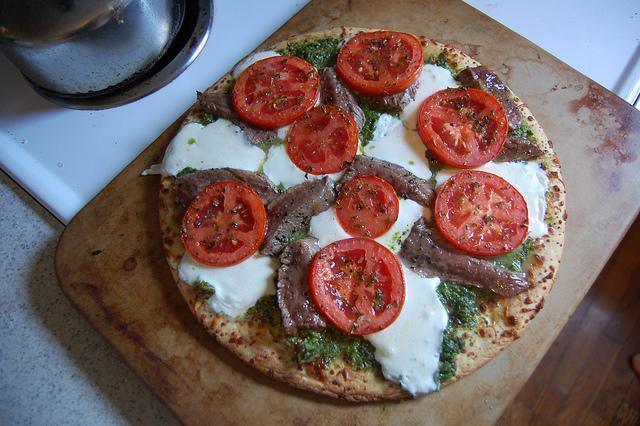How many slices of tomatoes do you see?
Give a very brief answer. 8. How many tomato slices are there?
Give a very brief answer. 8. 